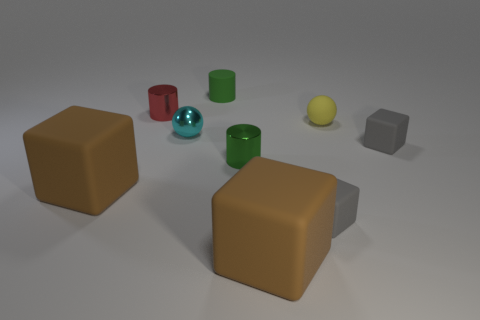Subtract 1 cylinders. How many cylinders are left? 2 Subtract all cylinders. How many objects are left? 6 Subtract 0 cyan cylinders. How many objects are left? 9 Subtract all tiny cyan things. Subtract all matte things. How many objects are left? 2 Add 5 big brown objects. How many big brown objects are left? 7 Add 5 big rubber objects. How many big rubber objects exist? 7 